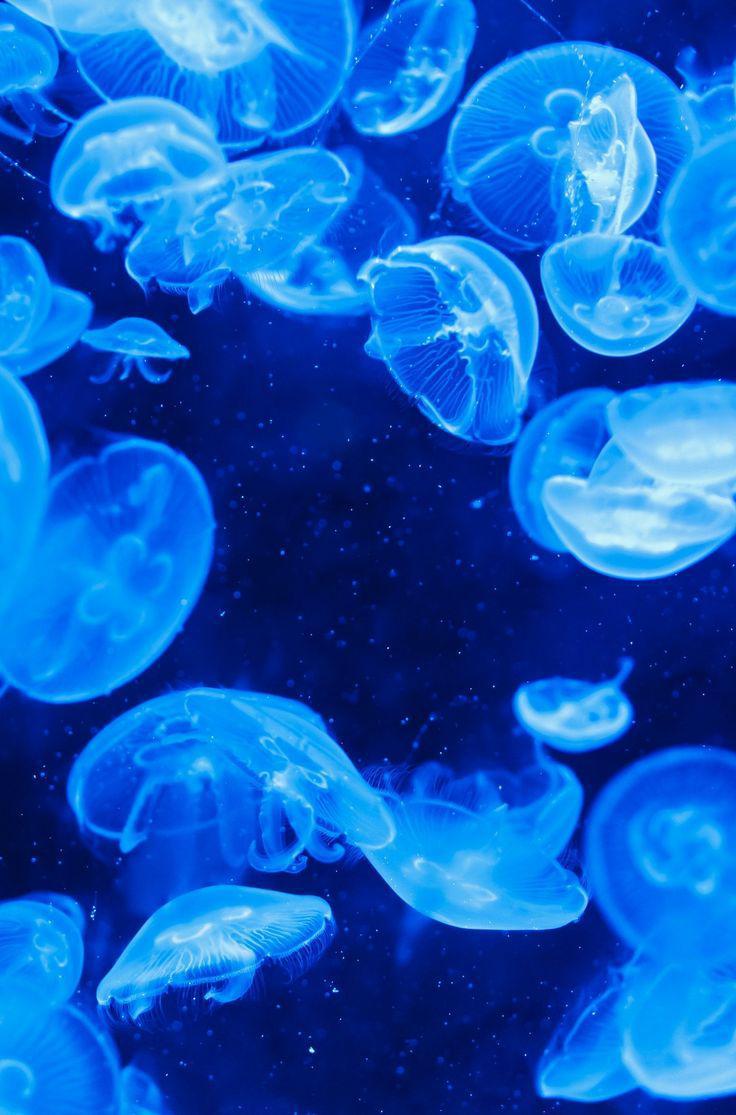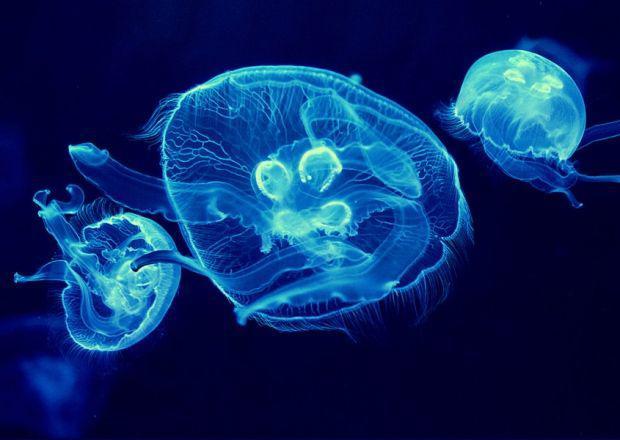The first image is the image on the left, the second image is the image on the right. Analyze the images presented: Is the assertion "In the image on the right, exactly 2  jellyfish are floating  above 1 smaller jellyfish." valid? Answer yes or no. No. 